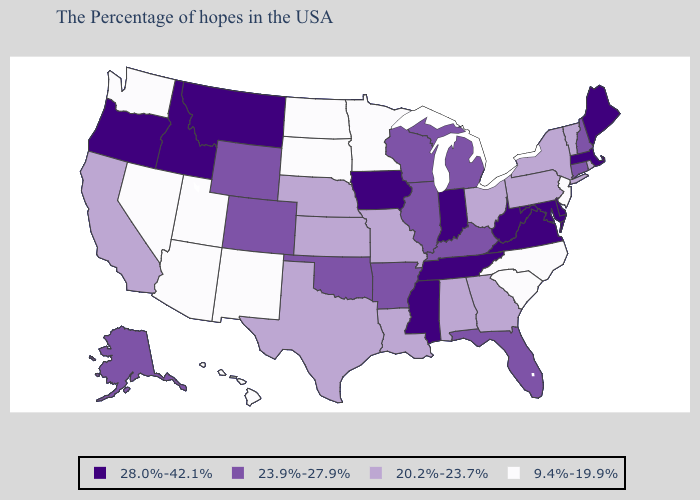What is the highest value in the USA?
Short answer required. 28.0%-42.1%. Does New Mexico have the highest value in the USA?
Concise answer only. No. Among the states that border Massachusetts , which have the lowest value?
Concise answer only. Rhode Island, Vermont, New York. Name the states that have a value in the range 28.0%-42.1%?
Be succinct. Maine, Massachusetts, Delaware, Maryland, Virginia, West Virginia, Indiana, Tennessee, Mississippi, Iowa, Montana, Idaho, Oregon. Does Nebraska have the lowest value in the MidWest?
Quick response, please. No. Does Florida have a higher value than Massachusetts?
Quick response, please. No. Which states hav the highest value in the South?
Write a very short answer. Delaware, Maryland, Virginia, West Virginia, Tennessee, Mississippi. Which states hav the highest value in the Northeast?
Short answer required. Maine, Massachusetts. What is the highest value in states that border Idaho?
Keep it brief. 28.0%-42.1%. What is the lowest value in the USA?
Concise answer only. 9.4%-19.9%. What is the value of Wyoming?
Be succinct. 23.9%-27.9%. What is the value of Maine?
Be succinct. 28.0%-42.1%. What is the value of West Virginia?
Be succinct. 28.0%-42.1%. What is the value of New Jersey?
Give a very brief answer. 9.4%-19.9%. 